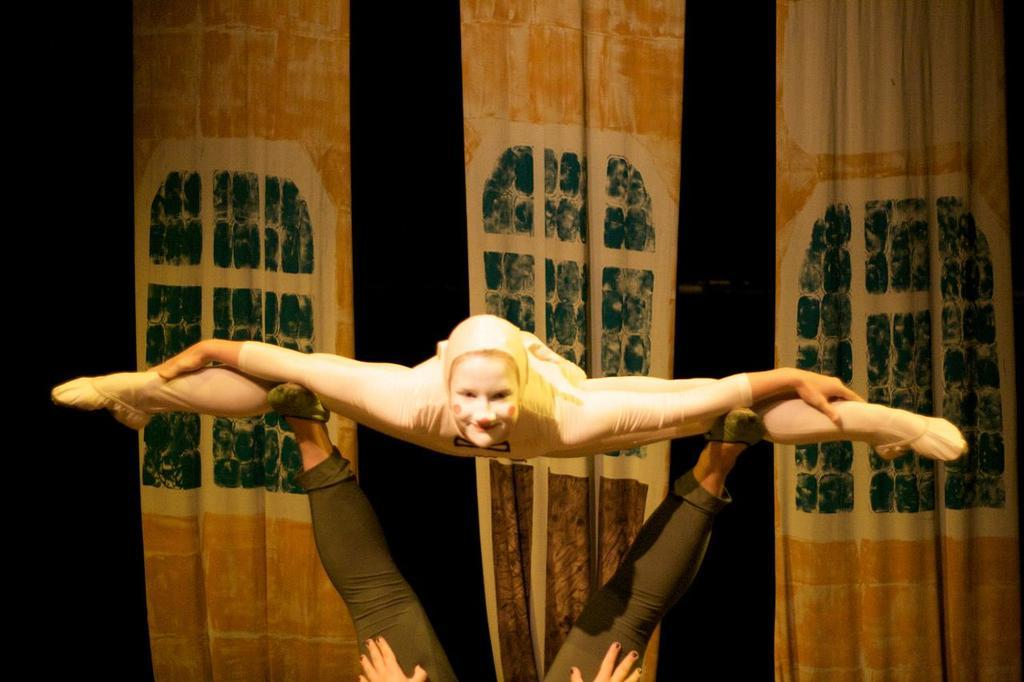How many people are in the image? There are two persons in the image. What are the two persons doing? The two persons are doing gymnastics. What can be seen hanging in the image? There are curtains in the image. What is the color of the background in the image? The background of the image is dark. Can you see a crate being used by the gymnasts in the image? No, there is no crate present in the image. Are the gymnasts trying to join a pear in the image? No, there is no pear present in the image, and the gymnasts are not attempting to join anything. 